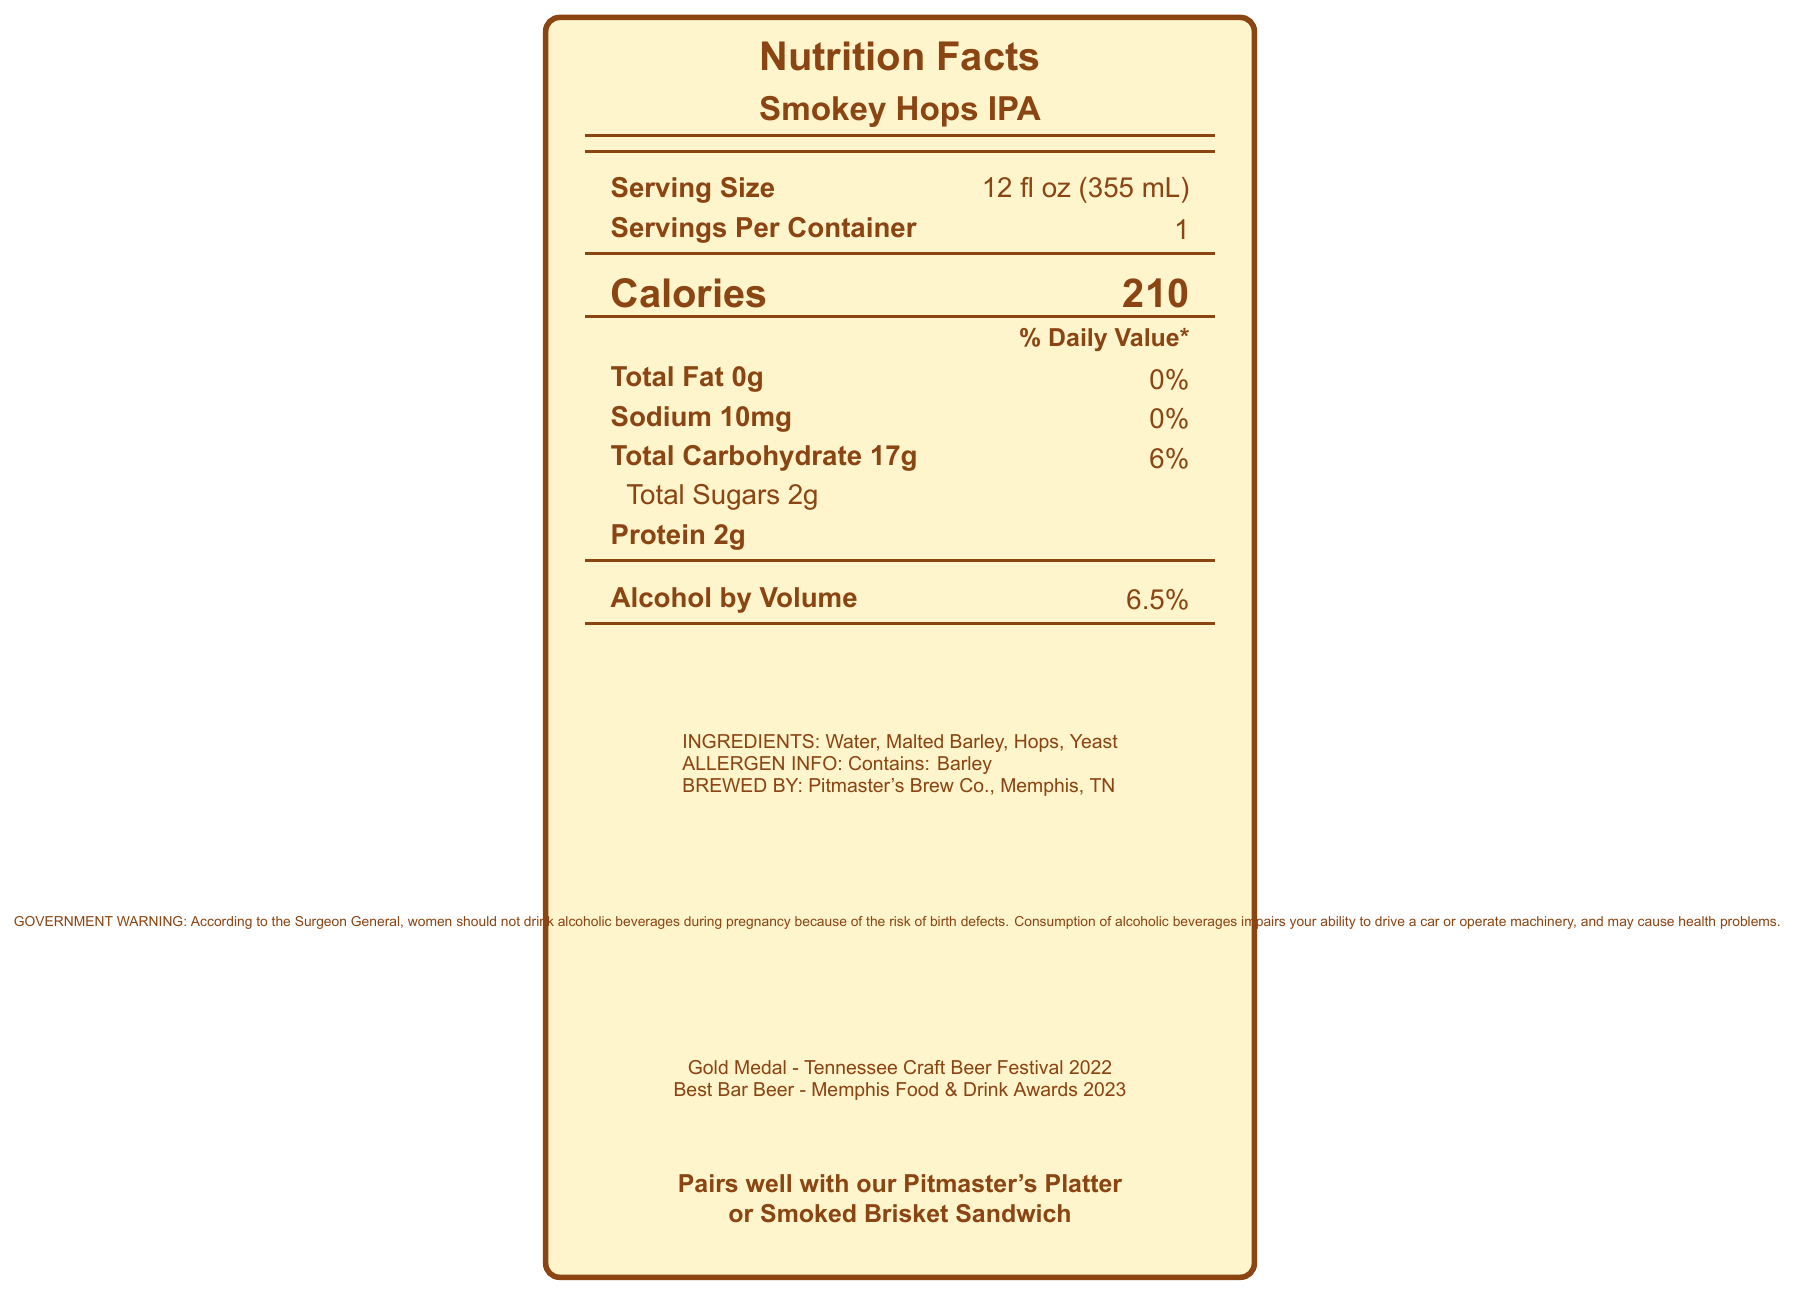what is the serving size of Smokey Hops IPA? The serving size is listed as "12 fl oz (355 mL)" in the document under "Serving Size".
Answer: 12 fl oz (355 mL) how many calories are in a serving of Smokey Hops IPA? The number of calories per serving is listed as "210" under "Calories".
Answer: 210 what is the total carbohydrate content per serving? The total carbohydrate content is specified as "17g" in the document.
Answer: 17g which ingredient in Smokey Hops IPA contains allergens? The allergen information is provided as "Contains: Barley".
Answer: Barley what is the alcohol by volume (ABV) of Smokey Hops IPA? The ABV is listed as "6.5%" under "Alcohol by Volume".
Answer: 6.5% what is the color of Smokey Hops IPA? The color of the beer is described as "Deep amber" in the additional info section.
Answer: Deep amber who is the brewer of Smokey Hops IPA? The brewer is listed as "Pitmaster's Brew Co." in the document.
Answer: Pitmaster's Brew Co. where is the brewery located? The brewery location is specified as "Memphis, TN".
Answer: Memphis, TN which of the following dishes pairs well with Smokey Hops IPA? A. Caesar Salad B. Pitmaster's Platter C. Margherita Pizza The document suggests Smokey Hops IPA pairs well with "Pitmaster's Platter" and "Smoked Brisket Sandwich".
Answer: B how many grams of protein are in a serving of Smokey Hops IPA? A. 1g B. 2g C. 3g D. 4g The amount of protein per serving is listed as "2g".
Answer: B how many awards has Smokey Hops IPA received in total? A. 1 B. 2 C. 3 D. 4 The document lists two awards: "Gold Medal - Tennessee Craft Beer Festival 2022" and "Best Bar Beer - Memphis Food & Drink Awards 2023".
Answer: B does Smokey Hops IPA contain any sodium? The document lists "Sodium 10mg" in the nutritional information.
Answer: Yes is it safe to consume Smokey Hops IPA during pregnancy? The government warning advises against consuming alcoholic beverages during pregnancy due to the risk of birth defects.
Answer: No summarize the main idea of the document. The document is a detailed description of Smokey Hops IPA, providing nutritional facts, ingredient information, pairing suggestions, brewery details, and awards won by the beer.
Answer: Smokey Hops IPA is a craft beer produced by Pitmaster's Brew Co. in Memphis, TN, with a serving size of 12 fl oz (355 mL) per container. It contains 210 calories, 0g of fat, 10mg of sodium, 17g of carbohydrates, 2g of protein, and has an ABV of 6.5%. The beer features ingredients like water, malted barley, hops, and yeast, and has won awards for its quality. It pairs well with BBQ dishes such as the Pitmaster's Platter and Smoked Brisket Sandwich. what is the contact information for Pitmaster's Brew Co.? The document does not provide any contact information for Pitmaster's Brew Co.
Answer: Not enough information 